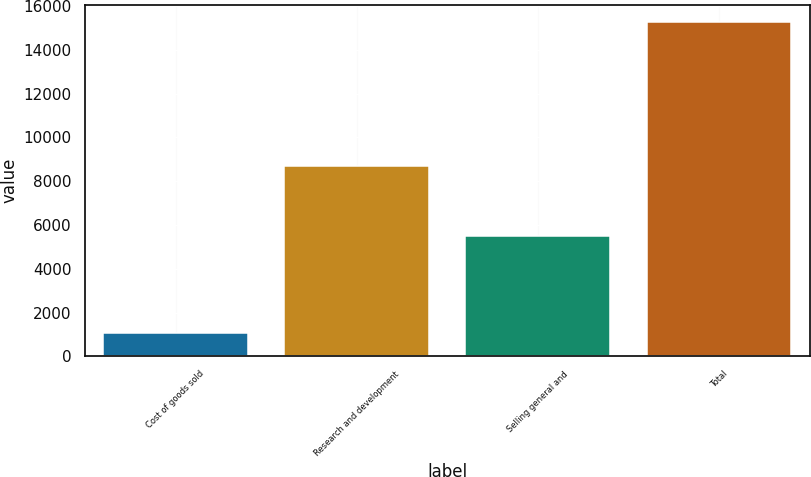Convert chart to OTSL. <chart><loc_0><loc_0><loc_500><loc_500><bar_chart><fcel>Cost of goods sold<fcel>Research and development<fcel>Selling general and<fcel>Total<nl><fcel>1071<fcel>8691<fcel>5517<fcel>15279<nl></chart> 